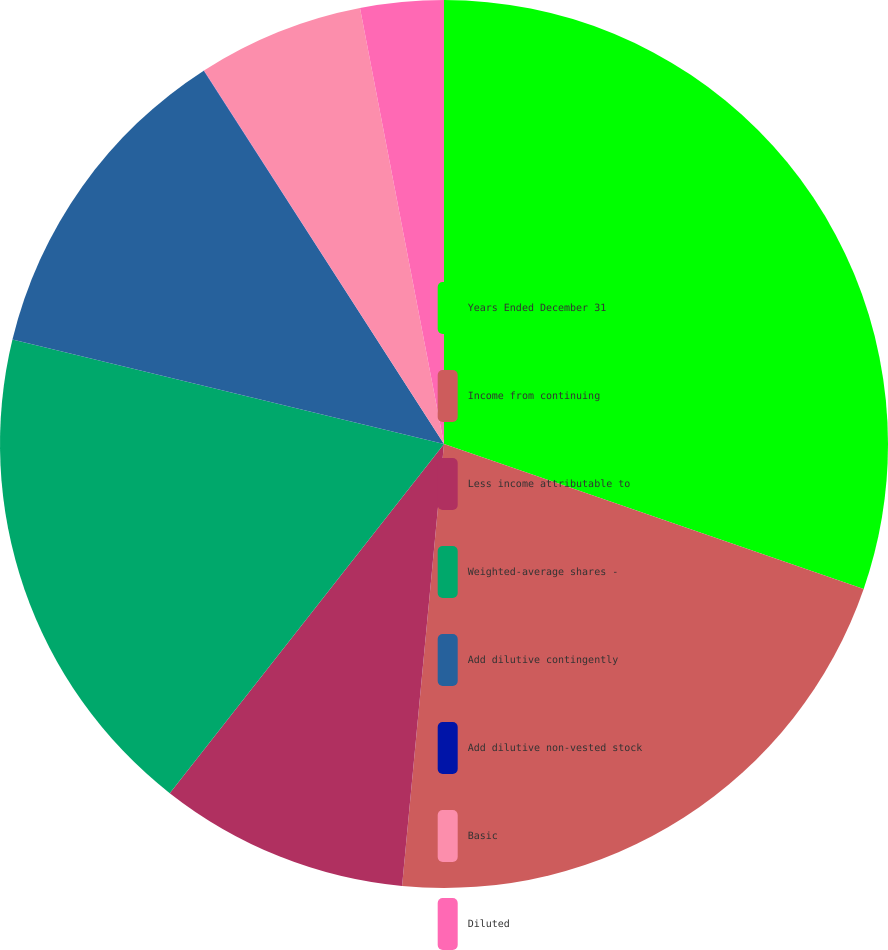<chart> <loc_0><loc_0><loc_500><loc_500><pie_chart><fcel>Years Ended December 31<fcel>Income from continuing<fcel>Less income attributable to<fcel>Weighted-average shares -<fcel>Add dilutive contingently<fcel>Add dilutive non-vested stock<fcel>Basic<fcel>Diluted<nl><fcel>30.29%<fcel>21.21%<fcel>9.09%<fcel>18.18%<fcel>12.12%<fcel>0.01%<fcel>6.06%<fcel>3.03%<nl></chart> 